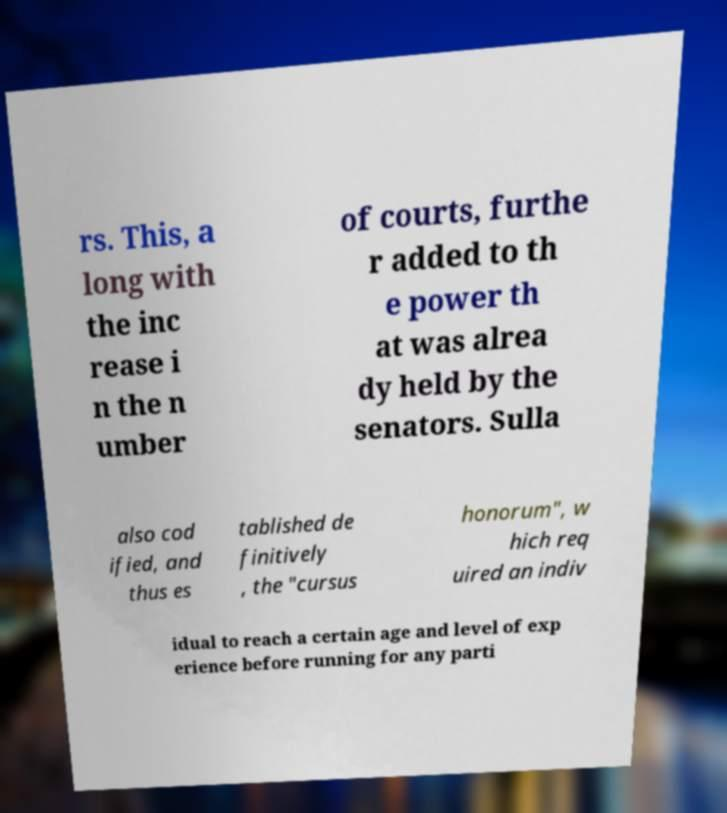Can you read and provide the text displayed in the image?This photo seems to have some interesting text. Can you extract and type it out for me? rs. This, a long with the inc rease i n the n umber of courts, furthe r added to th e power th at was alrea dy held by the senators. Sulla also cod ified, and thus es tablished de finitively , the "cursus honorum", w hich req uired an indiv idual to reach a certain age and level of exp erience before running for any parti 